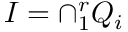Convert formula to latex. <formula><loc_0><loc_0><loc_500><loc_500>I = \cap _ { 1 } ^ { r } Q _ { i }</formula> 